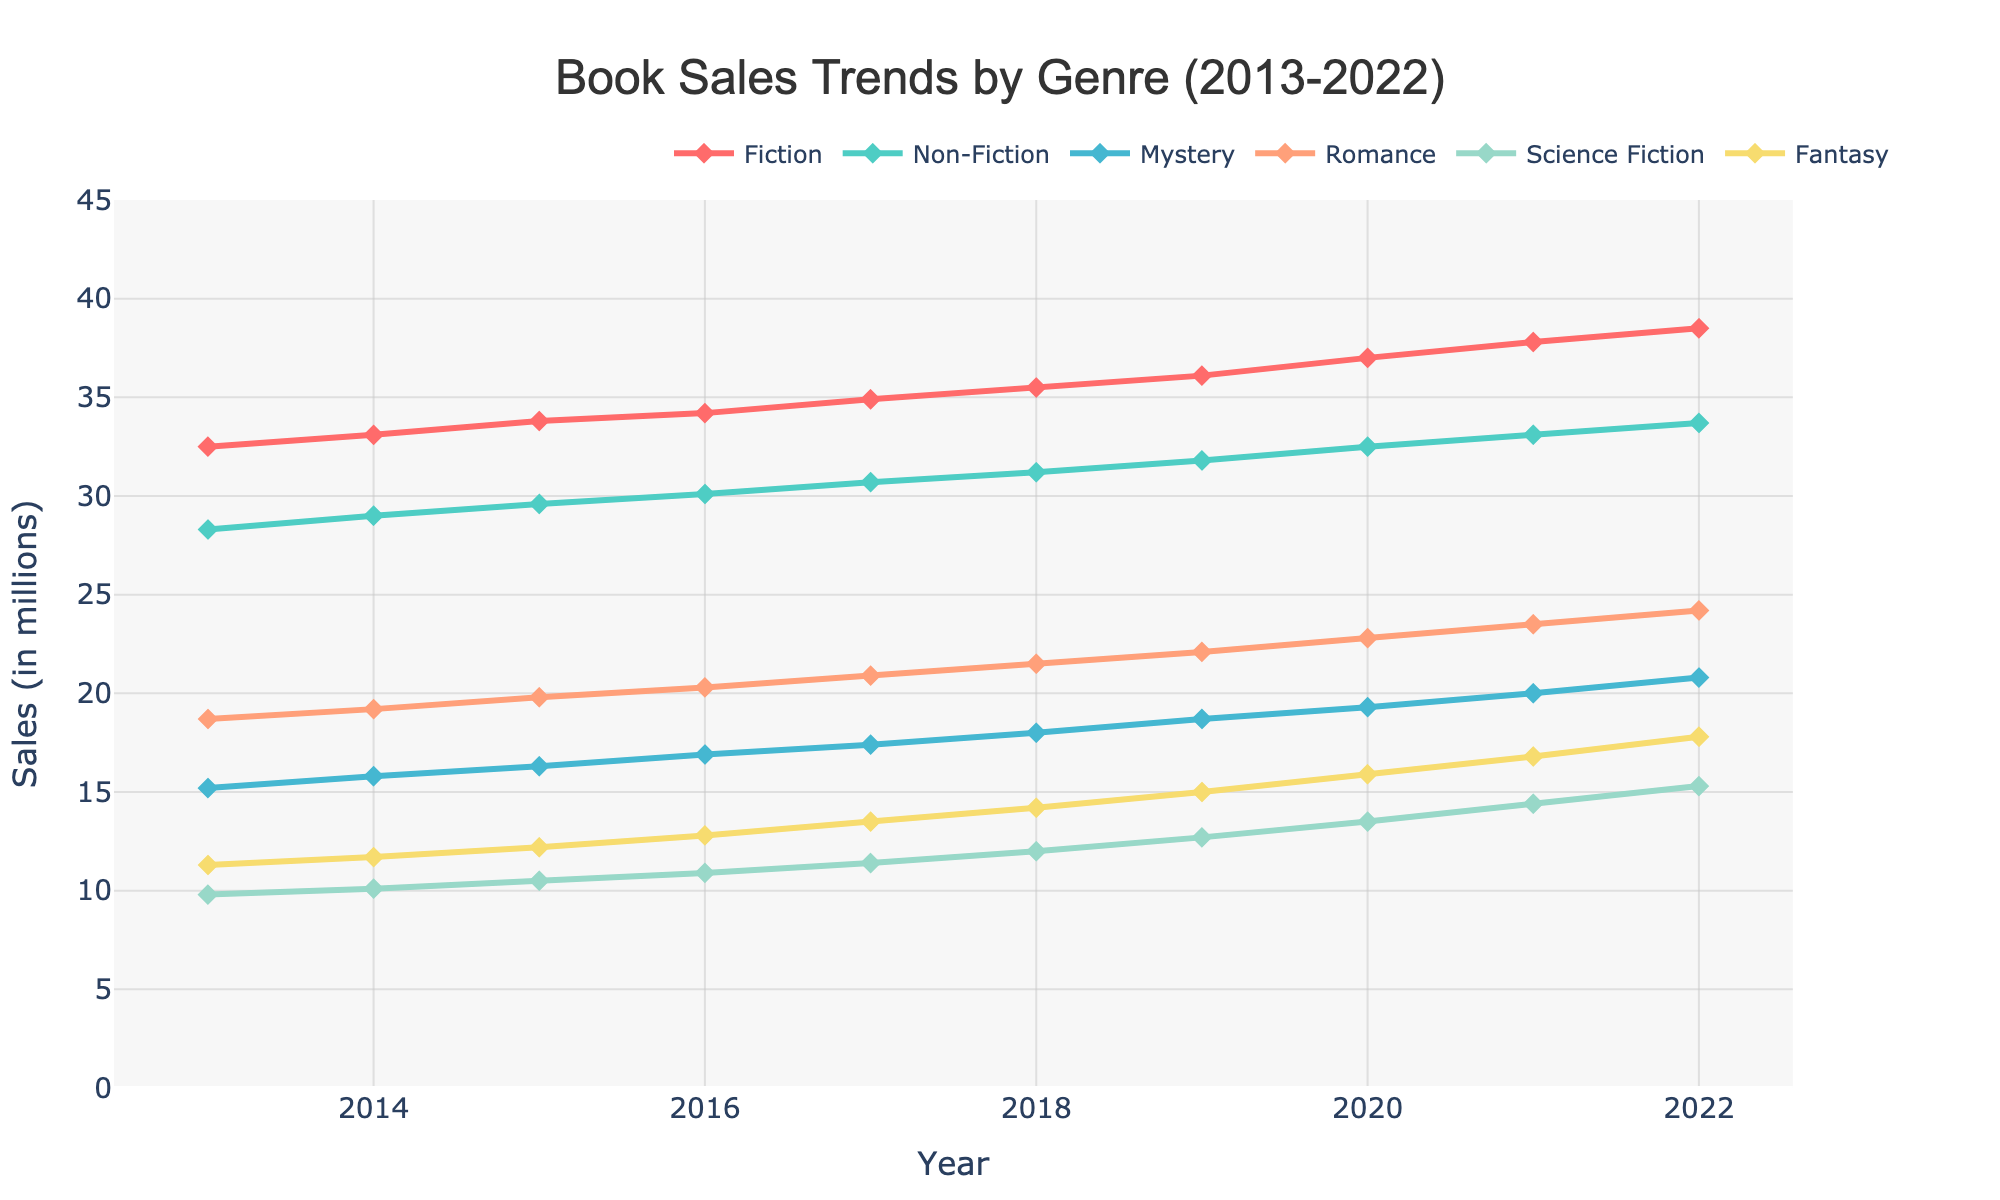What's the general trend for Fiction sales from 2013 to 2022? By looking at the plot, Fiction sales increase steadily over the period. The line representing Fiction sales generally slopes upwards from 2013 to 2022.
Answer: Increasing trend Which genre had the highest sales in 2022? In 2022, the genre with the highest sales can be identified by looking at the peak values of the lines. The line representing Fiction sales is the highest.
Answer: Fiction How do sales of Mystery compare to Romance in 2015? In 2015, the sales for Mystery and Romance can be compared by looking at their respective points on the graph. Mystery is at 16.3 million, and Romance is at 19.8 million. Romance sales are higher than Mystery.
Answer: Romance is higher What is the total increase in sales for Science Fiction from 2013 to 2022? To find the total increase, subtract the 2013 sales value from the 2022 sales value for Science Fiction. 15.3 million (2022) - 9.8 million (2013) = 5.5 million
Answer: 5.5 million Which genre shows the most consistent growth over the decade? Consistent growth is indicated by a smooth and steadily increasing line. Fiction shows this pattern, with no major dips or plateau periods, steadily increasing from 32.5 million to 38.5 million.
Answer: Fiction What's the average sales for Fantasy from 2013 to 2022? To calculate the average, sum the sales from 2013 to 2022 for Fantasy and divide by the number of years. The total is 144.2 million (11.3 + 11.7 + 12.2 + 12.8 + 13.5 + 14.2 + 15.0 + 15.9 + 16.8 + 17.8) divided by 10 years. Average = 144.2 / 10 = 14.42 million.
Answer: 14.42 million Did Non-Fiction sales ever surpass Fiction sales? By examining the overlapping lines for Non-Fiction and Fiction carefully, Non-Fiction sales never exceeded Fiction sales from 2013 to 2022. Fiction sales remained higher throughout the decade.
Answer: No Which two genres had the closest sales values in 2017? In 2017, visually inspect the lines to determine which genres had similar values. Romance and Mystery had closely aligned sales, around 20.9 and 17.4 million respectively.
Answer: Romance and Mystery By how much did Romance sales change from 2020 to 2022? Subtract the 2020 value from the 2022 value for Romance to get the change. 24.2 million (2022) - 22.8 million (2020) = 1.4 million.
Answer: 1.4 million Between 2018 and 2021, which genre experienced the highest cumulative increase in sales? Calculate the differences in sales for each genre from 2018 to 2021 and sum them. Fiction: 37.8 - 35.5 = 2.3, Romance: 23.5 - 21.5 = 2.0, Science Fiction: 14.4 - 12.0 = 2.4. Science Fiction had the highest increase in this period.
Answer: Science Fiction 